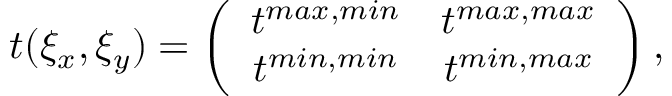<formula> <loc_0><loc_0><loc_500><loc_500>t ( \xi _ { x } , \xi _ { y } ) = \left ( \begin{array} { c c } { t ^ { \max , \min } } & { t ^ { \max , \max } } \\ { t ^ { \min , \min } } & { t ^ { \min , \max } } \end{array} \right ) ,</formula> 